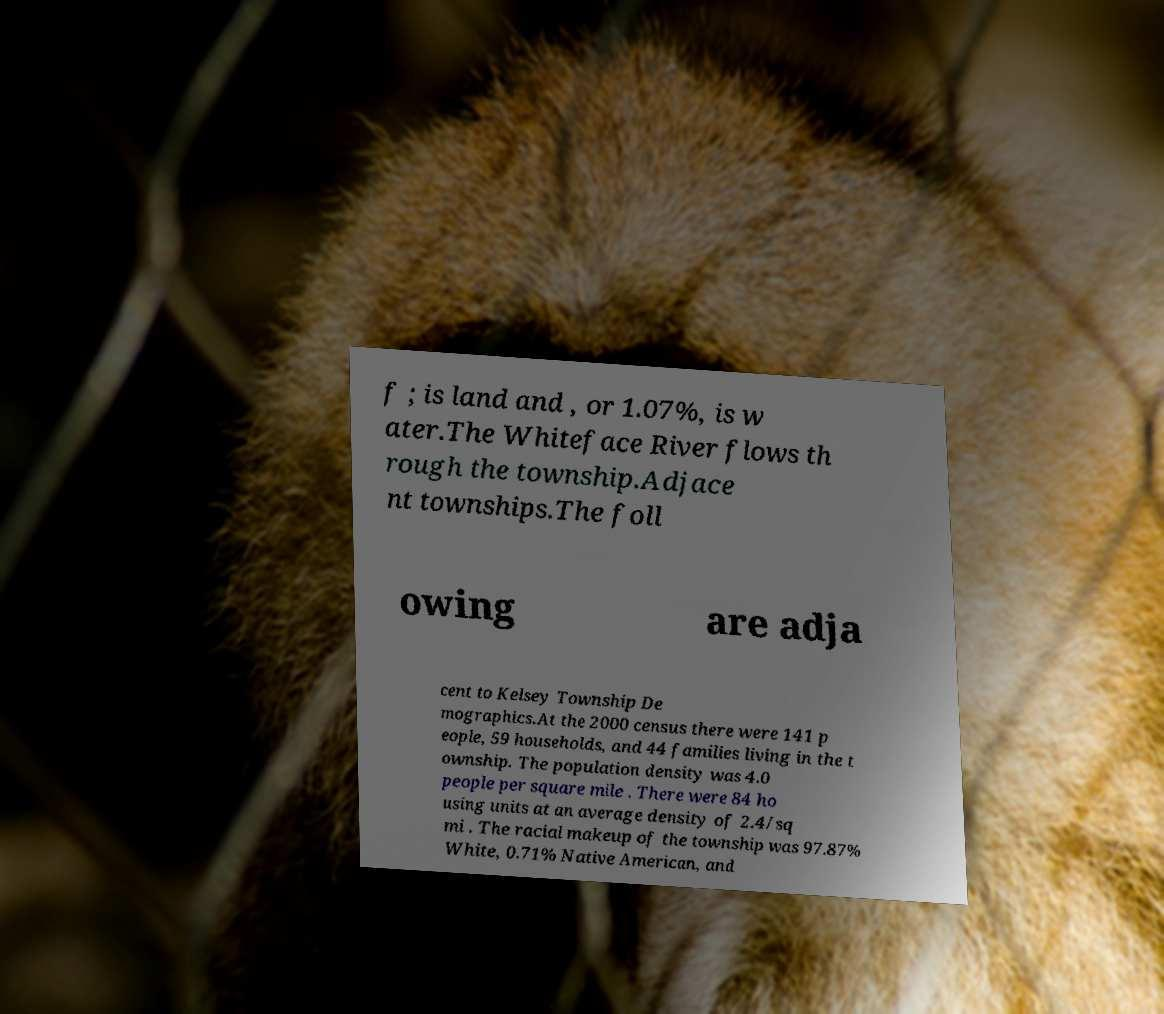Please identify and transcribe the text found in this image. f ; is land and , or 1.07%, is w ater.The Whiteface River flows th rough the township.Adjace nt townships.The foll owing are adja cent to Kelsey Township De mographics.At the 2000 census there were 141 p eople, 59 households, and 44 families living in the t ownship. The population density was 4.0 people per square mile . There were 84 ho using units at an average density of 2.4/sq mi . The racial makeup of the township was 97.87% White, 0.71% Native American, and 